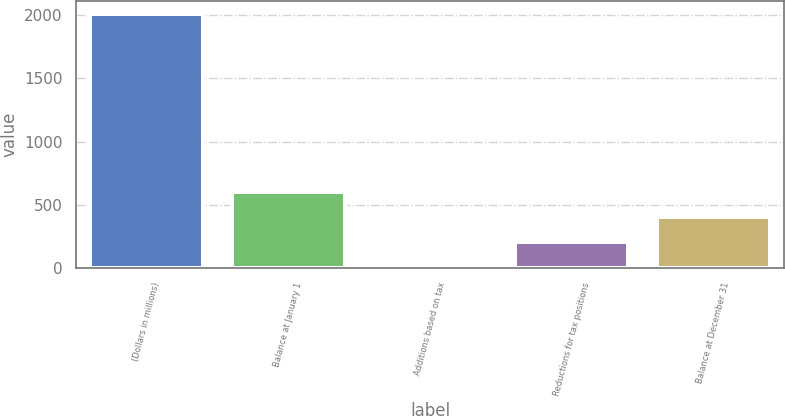Convert chart. <chart><loc_0><loc_0><loc_500><loc_500><bar_chart><fcel>(Dollars in millions)<fcel>Balance at January 1<fcel>Additions based on tax<fcel>Reductions for tax positions<fcel>Balance at December 31<nl><fcel>2009<fcel>603.96<fcel>1.8<fcel>202.52<fcel>403.24<nl></chart> 